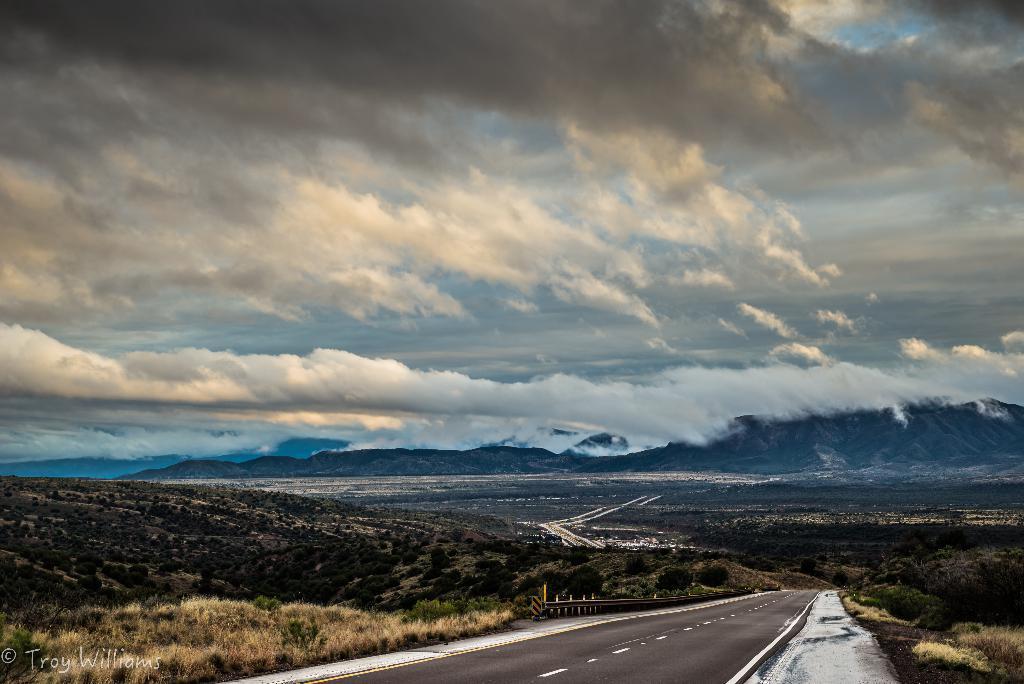Could you give a brief overview of what you see in this image? In this image there is the sky truncated towards the top of the image, there are clouds in the sky, there are mountains, the mountains truncated towards the right of the image, there are plants, there are plants truncated towards the right of the image, there are plants truncated towards the left of the image, there are plants truncated towards the bottom of the image, there is road truncated towards the bottom of the image, there is the text truncated towards the bottom of the image. 